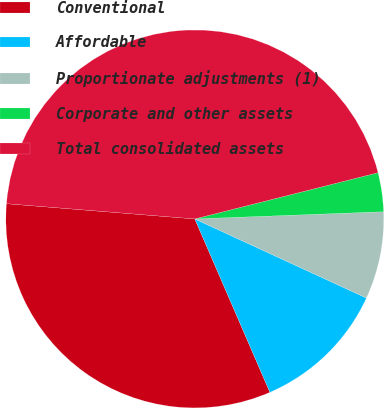<chart> <loc_0><loc_0><loc_500><loc_500><pie_chart><fcel>Conventional<fcel>Affordable<fcel>Proportionate adjustments (1)<fcel>Corporate and other assets<fcel>Total consolidated assets<nl><fcel>32.79%<fcel>11.62%<fcel>7.48%<fcel>3.33%<fcel>44.78%<nl></chart> 